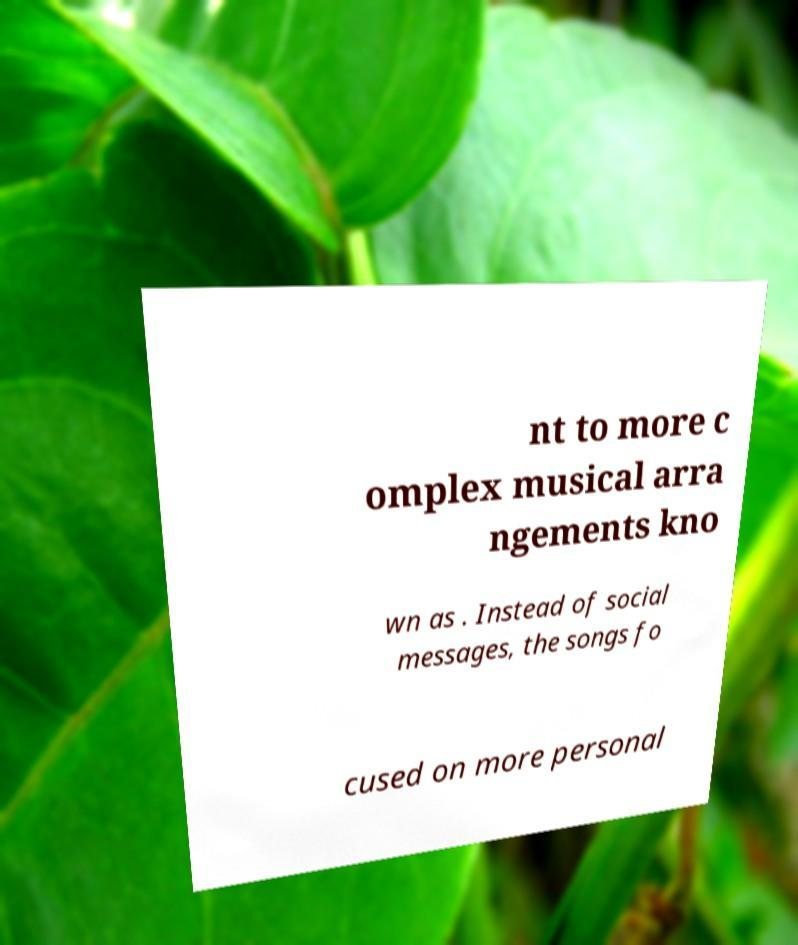I need the written content from this picture converted into text. Can you do that? nt to more c omplex musical arra ngements kno wn as . Instead of social messages, the songs fo cused on more personal 